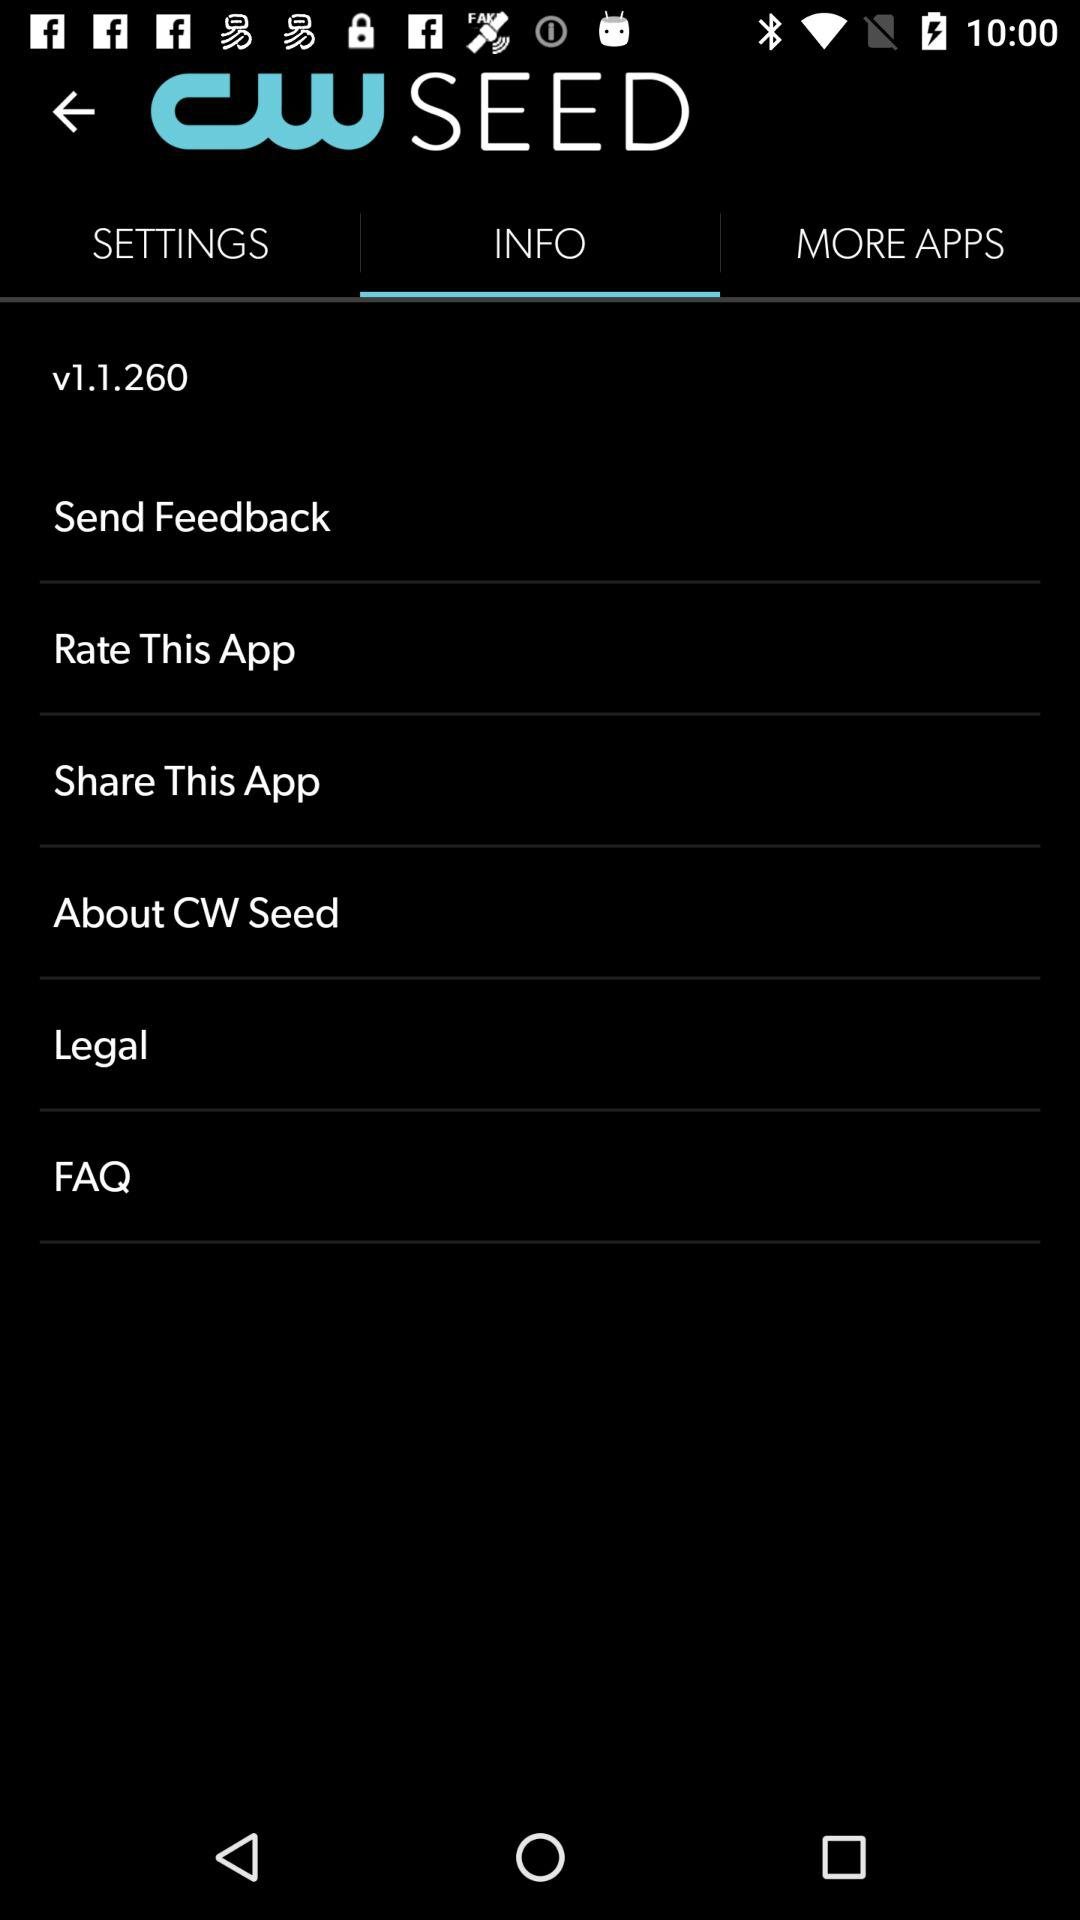Which is the selected tab? The selected tab is "INFO". 